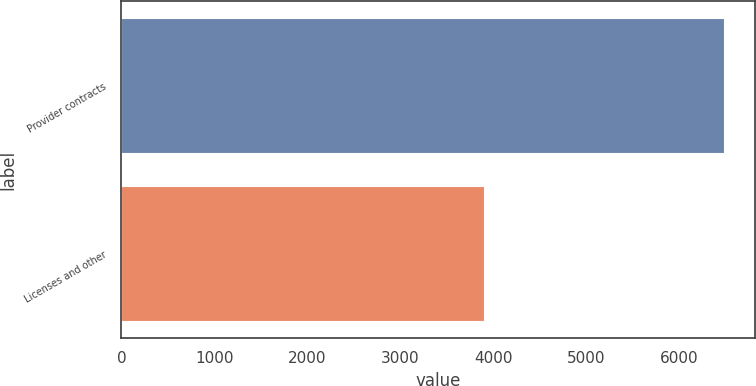Convert chart to OTSL. <chart><loc_0><loc_0><loc_500><loc_500><bar_chart><fcel>Provider contracts<fcel>Licenses and other<nl><fcel>6484<fcel>3904<nl></chart> 